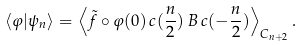Convert formula to latex. <formula><loc_0><loc_0><loc_500><loc_500>\langle \varphi | \psi _ { n } \rangle = \left \langle \tilde { f } \circ \varphi ( 0 ) \, c ( \frac { n } { 2 } ) \, B \, c ( - \frac { n } { 2 } ) \right \rangle _ { C _ { n + 2 } } .</formula> 